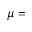Convert formula to latex. <formula><loc_0><loc_0><loc_500><loc_500>\mu =</formula> 